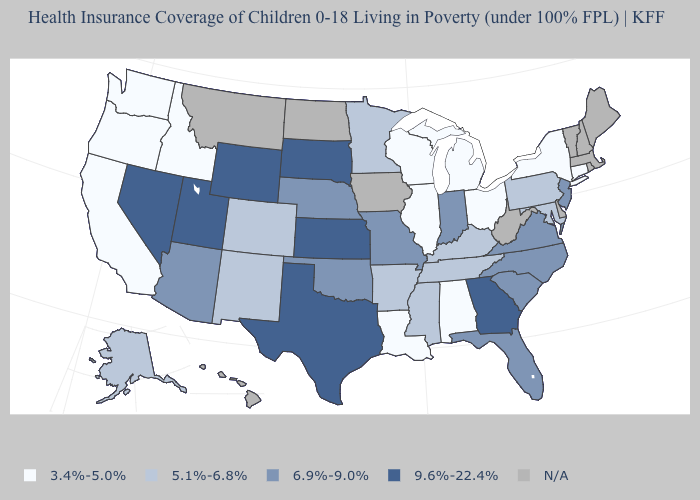What is the value of Connecticut?
Concise answer only. 3.4%-5.0%. Which states have the lowest value in the MidWest?
Answer briefly. Illinois, Michigan, Ohio, Wisconsin. What is the value of Virginia?
Short answer required. 6.9%-9.0%. Which states have the lowest value in the MidWest?
Keep it brief. Illinois, Michigan, Ohio, Wisconsin. Does the first symbol in the legend represent the smallest category?
Concise answer only. Yes. Is the legend a continuous bar?
Quick response, please. No. What is the lowest value in states that border Vermont?
Give a very brief answer. 3.4%-5.0%. Name the states that have a value in the range 3.4%-5.0%?
Give a very brief answer. Alabama, California, Connecticut, Idaho, Illinois, Louisiana, Michigan, New York, Ohio, Oregon, Washington, Wisconsin. Name the states that have a value in the range 3.4%-5.0%?
Keep it brief. Alabama, California, Connecticut, Idaho, Illinois, Louisiana, Michigan, New York, Ohio, Oregon, Washington, Wisconsin. Which states have the lowest value in the USA?
Answer briefly. Alabama, California, Connecticut, Idaho, Illinois, Louisiana, Michigan, New York, Ohio, Oregon, Washington, Wisconsin. Among the states that border California , which have the highest value?
Quick response, please. Nevada. What is the value of Missouri?
Be succinct. 6.9%-9.0%. Is the legend a continuous bar?
Write a very short answer. No. What is the highest value in the USA?
Keep it brief. 9.6%-22.4%. Name the states that have a value in the range 6.9%-9.0%?
Be succinct. Arizona, Florida, Indiana, Missouri, Nebraska, New Jersey, North Carolina, Oklahoma, South Carolina, Virginia. 